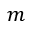<formula> <loc_0><loc_0><loc_500><loc_500>m</formula> 